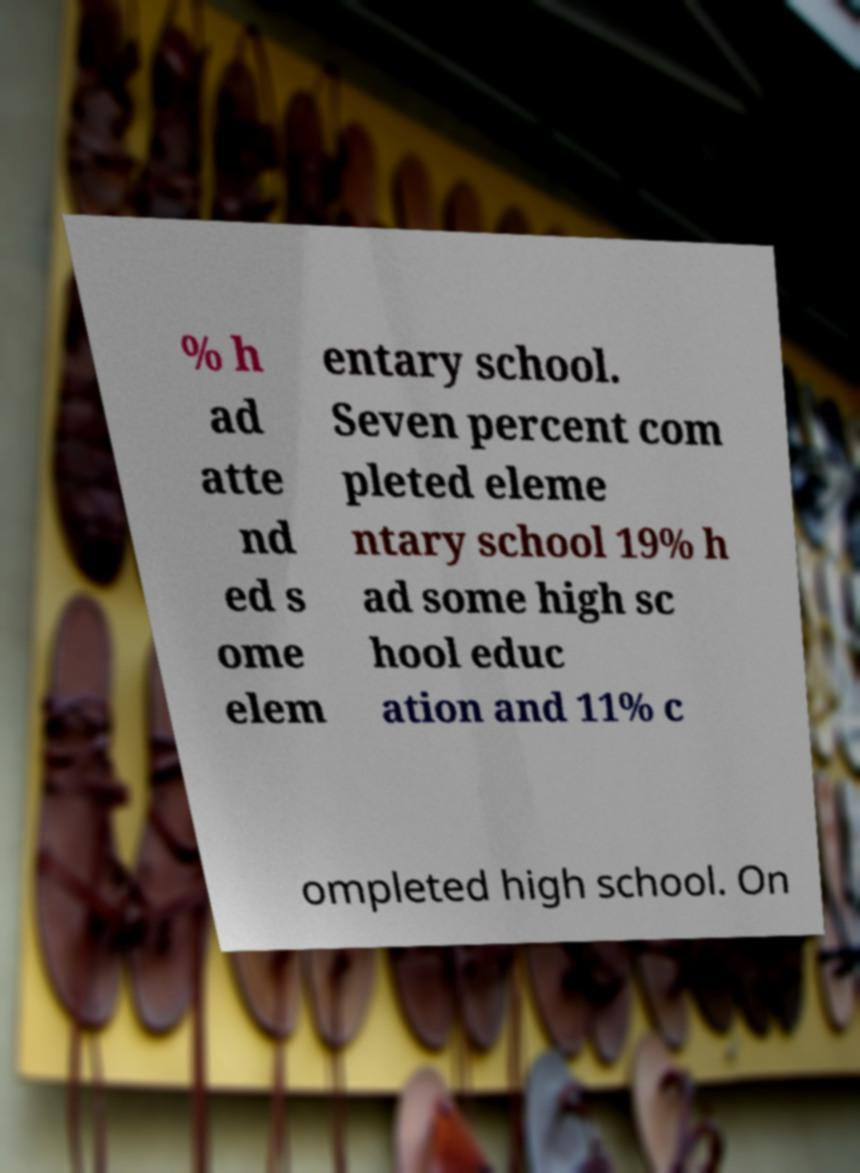Please identify and transcribe the text found in this image. % h ad atte nd ed s ome elem entary school. Seven percent com pleted eleme ntary school 19% h ad some high sc hool educ ation and 11% c ompleted high school. On 